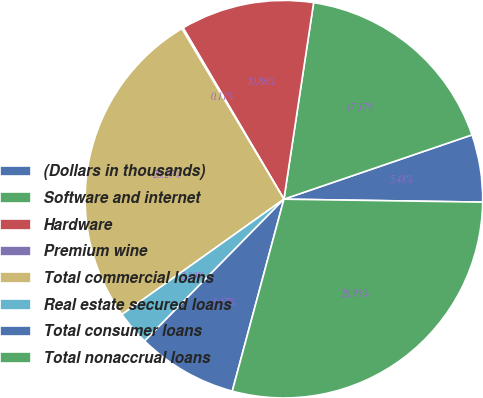<chart> <loc_0><loc_0><loc_500><loc_500><pie_chart><fcel>(Dollars in thousands)<fcel>Software and internet<fcel>Hardware<fcel>Premium wine<fcel>Total commercial loans<fcel>Real estate secured loans<fcel>Total consumer loans<fcel>Total nonaccrual loans<nl><fcel>5.48%<fcel>17.37%<fcel>10.86%<fcel>0.11%<fcel>26.27%<fcel>2.8%<fcel>8.17%<fcel>28.95%<nl></chart> 